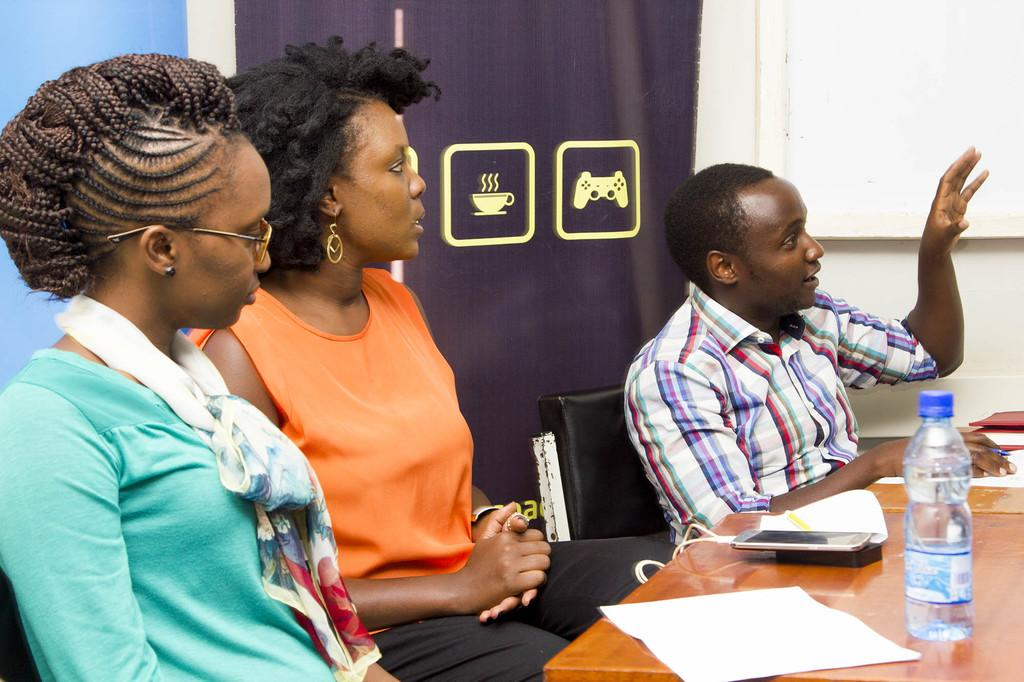How many people are in the image? There are three people in the image: two women and a man. What is the man doing in the image? The man is sitting on a chair. Where is the chair located in relation to the table? The chair is in front of the table. What can be seen on the table in the image? There is a bottle and other objects on the table. Can you see any lakes or roses in the image? No, there are no lakes or roses present in the image. Is there a bomb visible on the table in the image? No, there is no bomb visible on the table in the image. 